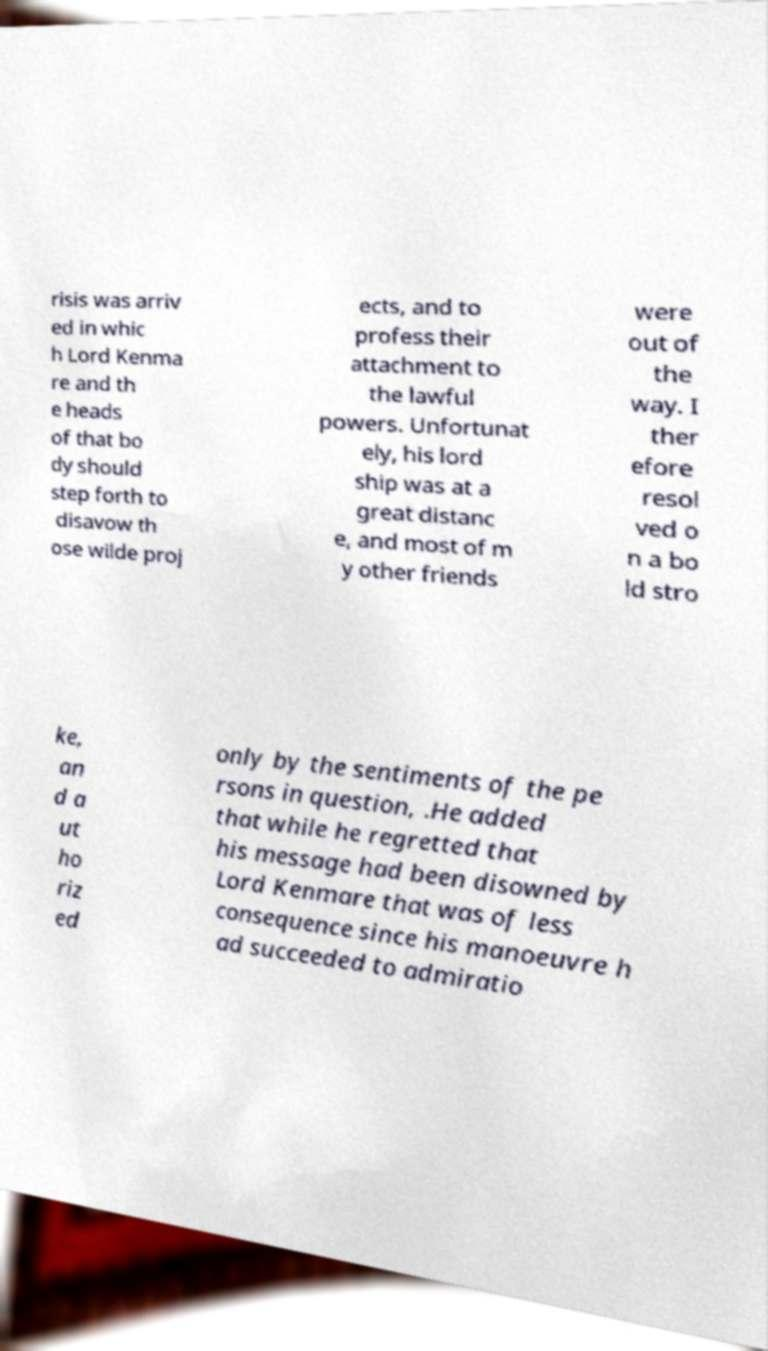Could you extract and type out the text from this image? risis was arriv ed in whic h Lord Kenma re and th e heads of that bo dy should step forth to disavow th ose wilde proj ects, and to profess their attachment to the lawful powers. Unfortunat ely, his lord ship was at a great distanc e, and most of m y other friends were out of the way. I ther efore resol ved o n a bo ld stro ke, an d a ut ho riz ed only by the sentiments of the pe rsons in question, .He added that while he regretted that his message had been disowned by Lord Kenmare that was of less consequence since his manoeuvre h ad succeeded to admiratio 